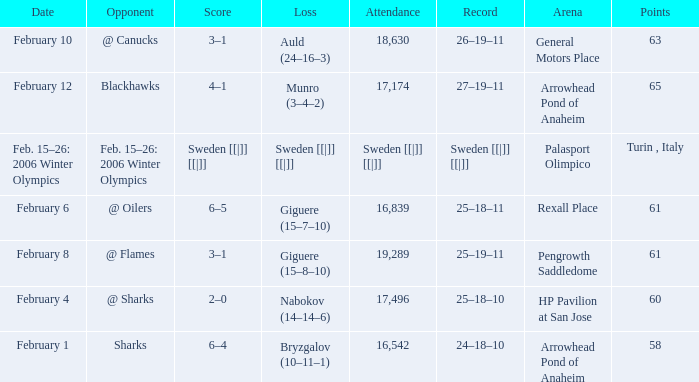What is the record at Arrowhead Pond of Anaheim, when the loss was Bryzgalov (10–11–1)? 24–18–10. 